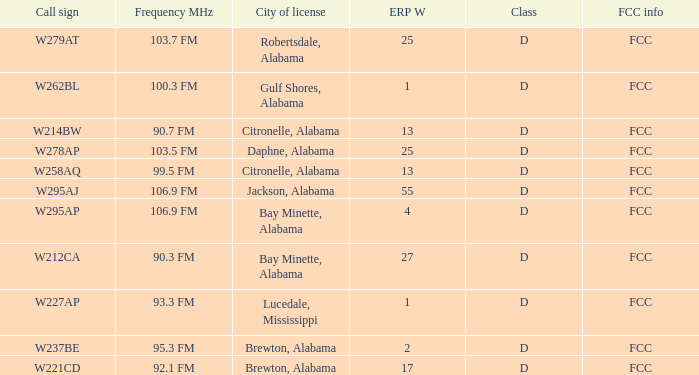Name the call sign for ERP W of 27 W212CA. 